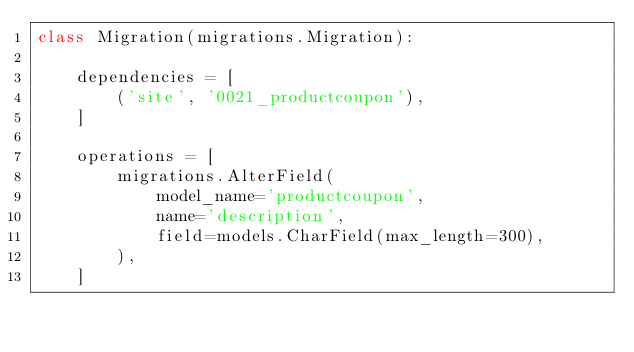<code> <loc_0><loc_0><loc_500><loc_500><_Python_>class Migration(migrations.Migration):

    dependencies = [
        ('site', '0021_productcoupon'),
    ]

    operations = [
        migrations.AlterField(
            model_name='productcoupon',
            name='description',
            field=models.CharField(max_length=300),
        ),
    ]
</code> 